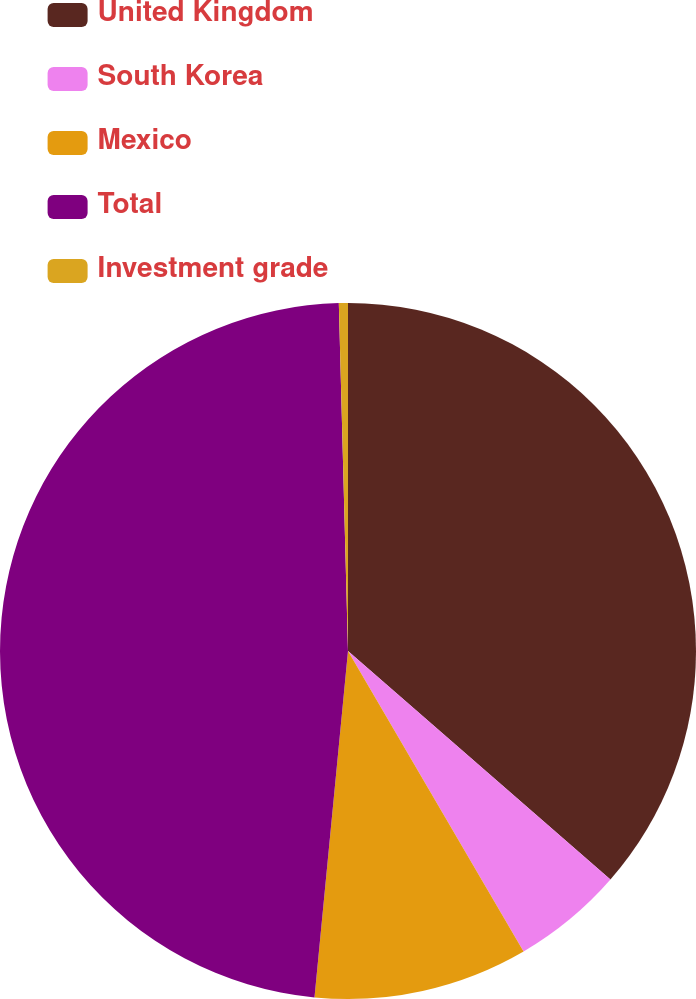Convert chart. <chart><loc_0><loc_0><loc_500><loc_500><pie_chart><fcel>United Kingdom<fcel>South Korea<fcel>Mexico<fcel>Total<fcel>Investment grade<nl><fcel>36.4%<fcel>5.18%<fcel>9.95%<fcel>48.04%<fcel>0.42%<nl></chart> 